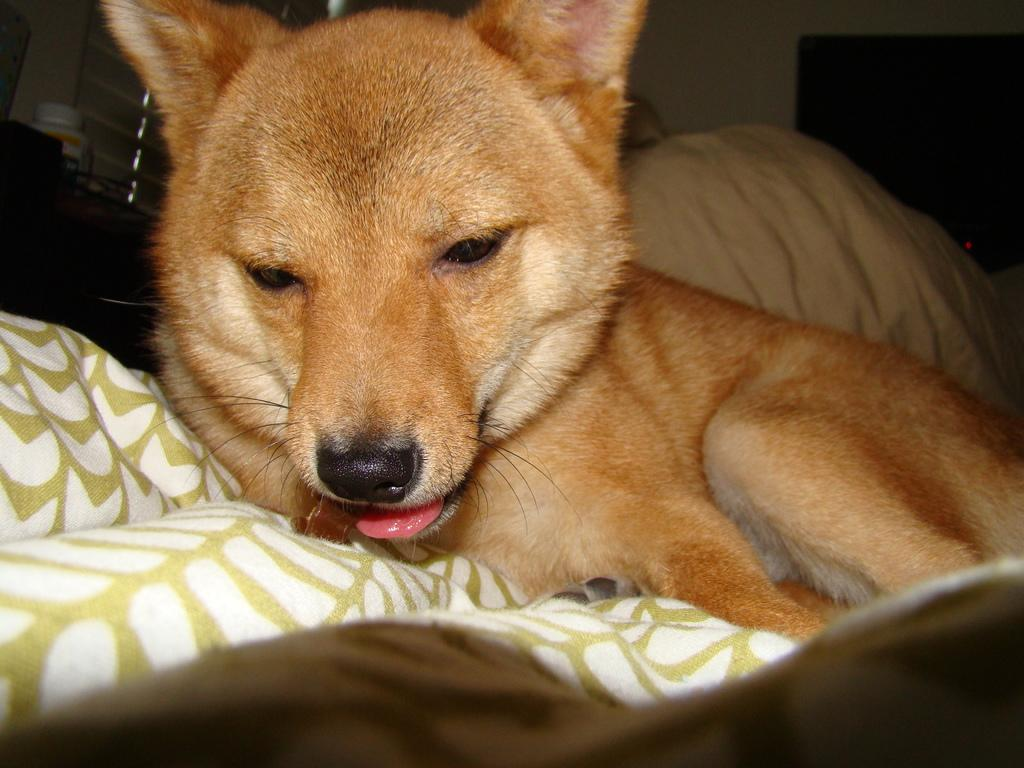What type of animal is in the image? There is a dog in the image. What is the dog doing in the image? The dog is laying on a blanket. What color is the dog in the image? The dog is brown in color. What colors are present on the blanket the dog is laying on? The blanket is white and green in color. What type of noise can be heard coming from the hole in the image? There is no hole present in the image, so it is not possible to determine what noise might be heard. 